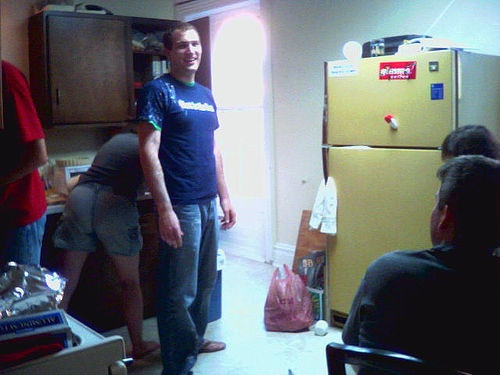Describe the objects in this image and their specific colors. I can see refrigerator in maroon, olive, khaki, darkgray, and gray tones, people in maroon, black, navy, blue, and gray tones, people in maroon, black, navy, blue, and lavender tones, people in maroon, black, gray, and darkblue tones, and people in maroon, black, brown, and navy tones in this image. 